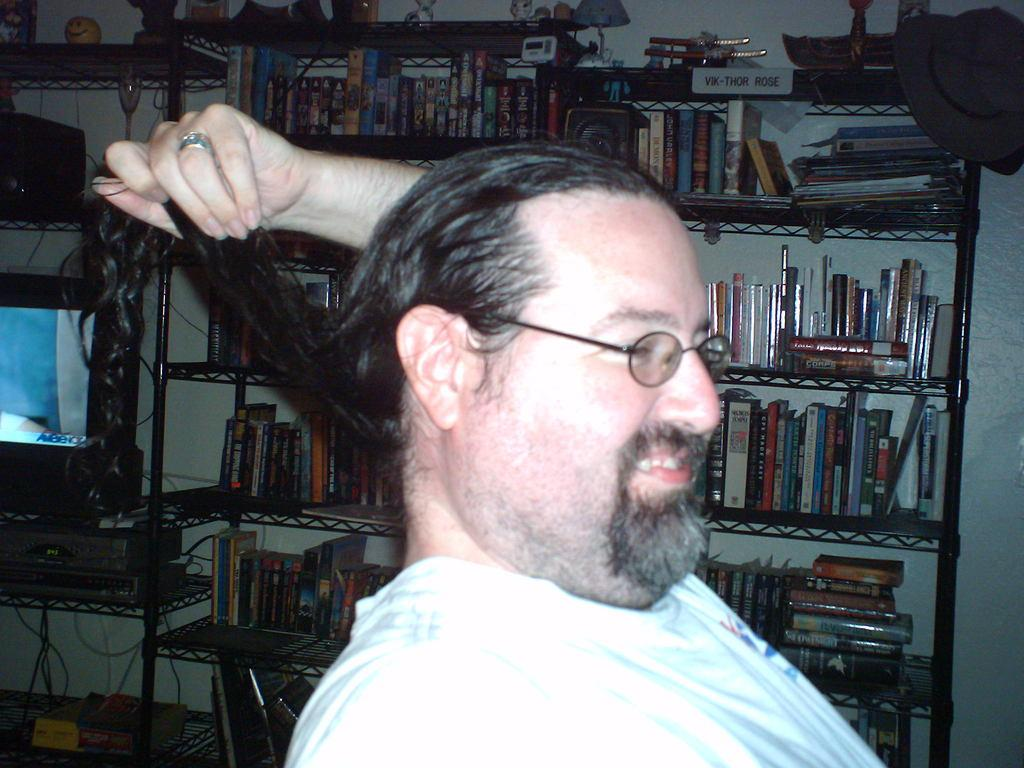What is the main subject in the foreground of the image? There is a man in the foreground of the image. What is the man doing in the image? The man is holding his hair in the image. What can be seen in the background of the image? There are books, a monitor, and other items in the background of the image. What is the man protesting about in the image? There is no indication in the image that the man is protesting or expressing any particular sentiment. 